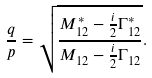Convert formula to latex. <formula><loc_0><loc_0><loc_500><loc_500>\frac { q } { p } = \sqrt { \frac { M _ { 1 2 } ^ { * } - \frac { i } { 2 } \Gamma _ { 1 2 } ^ { * } } { M _ { 1 2 } - \frac { i } { 2 } \Gamma _ { 1 2 } } } .</formula> 